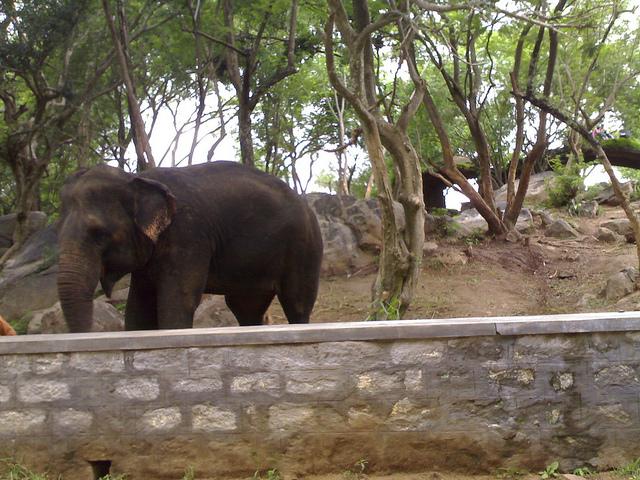What is the wall made of?
Write a very short answer. Stone. Is the elephant's eyes closed?
Answer briefly. No. Is it daytime?
Answer briefly. Yes. What is the baby elephant doing near the wall?
Write a very short answer. Standing. 